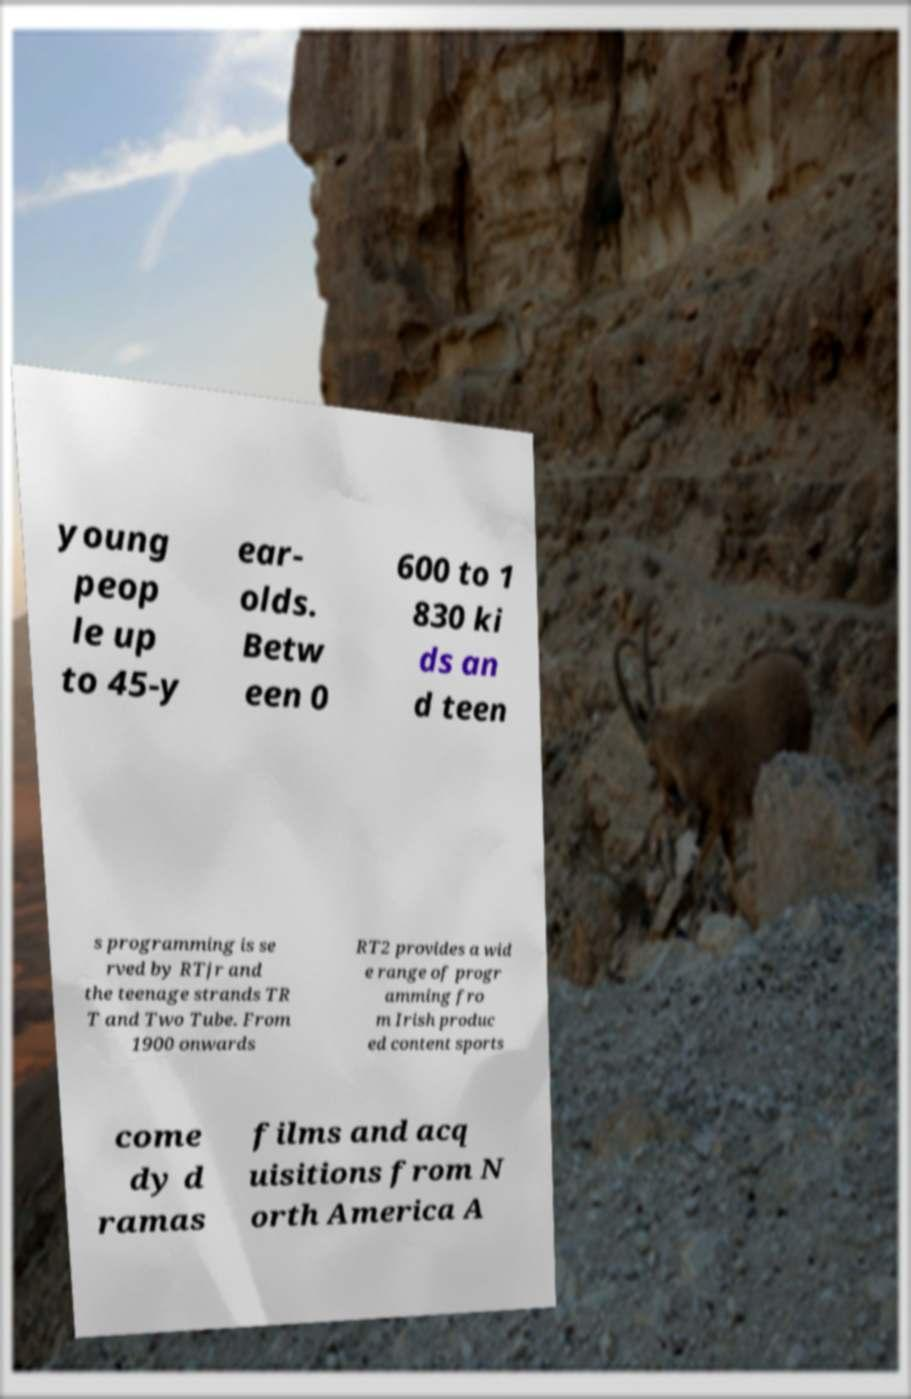Please read and relay the text visible in this image. What does it say? young peop le up to 45-y ear- olds. Betw een 0 600 to 1 830 ki ds an d teen s programming is se rved by RTjr and the teenage strands TR T and Two Tube. From 1900 onwards RT2 provides a wid e range of progr amming fro m Irish produc ed content sports come dy d ramas films and acq uisitions from N orth America A 